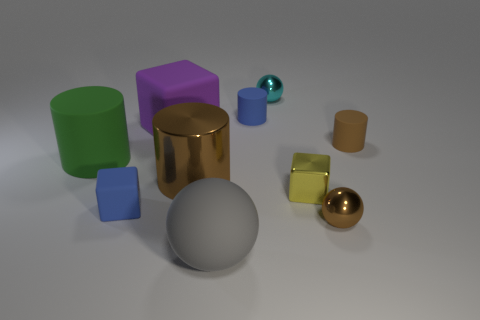Subtract all red cylinders. Subtract all yellow cubes. How many cylinders are left? 4 Subtract all spheres. How many objects are left? 7 Add 3 tiny metallic spheres. How many tiny metallic spheres exist? 5 Subtract 1 yellow cubes. How many objects are left? 9 Subtract all small blocks. Subtract all big matte cylinders. How many objects are left? 7 Add 1 green matte cylinders. How many green matte cylinders are left? 2 